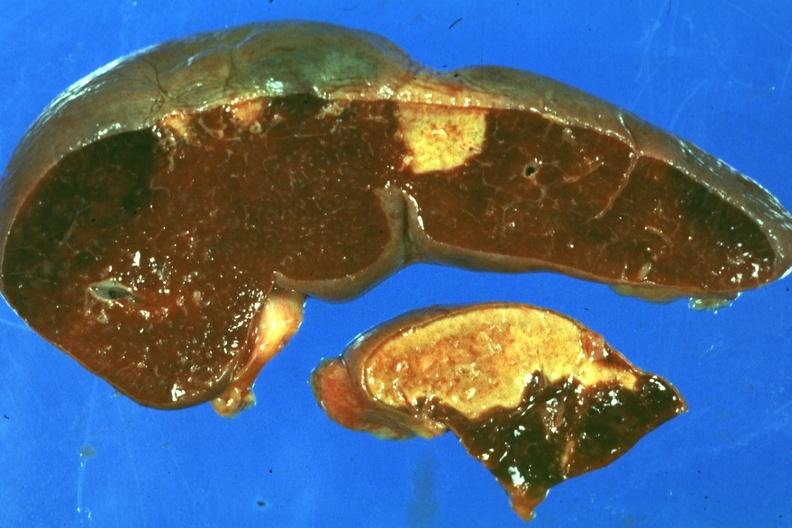s face present?
Answer the question using a single word or phrase. No 